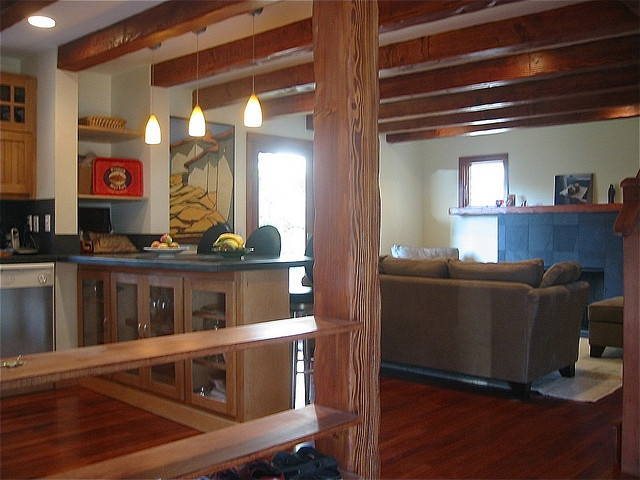Describe the objects in this image and their specific colors. I can see couch in black, maroon, and gray tones, dining table in black, gray, and blue tones, chair in black, white, gray, and darkblue tones, chair in black, gray, and maroon tones, and chair in black, gray, and purple tones in this image. 